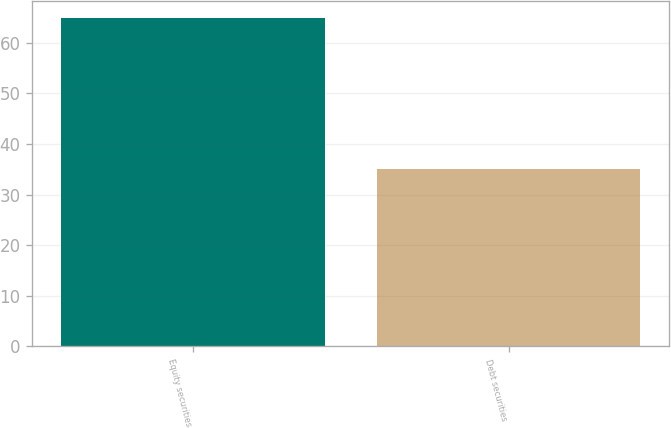Convert chart to OTSL. <chart><loc_0><loc_0><loc_500><loc_500><bar_chart><fcel>Equity securities<fcel>Debt securities<nl><fcel>65<fcel>35<nl></chart> 